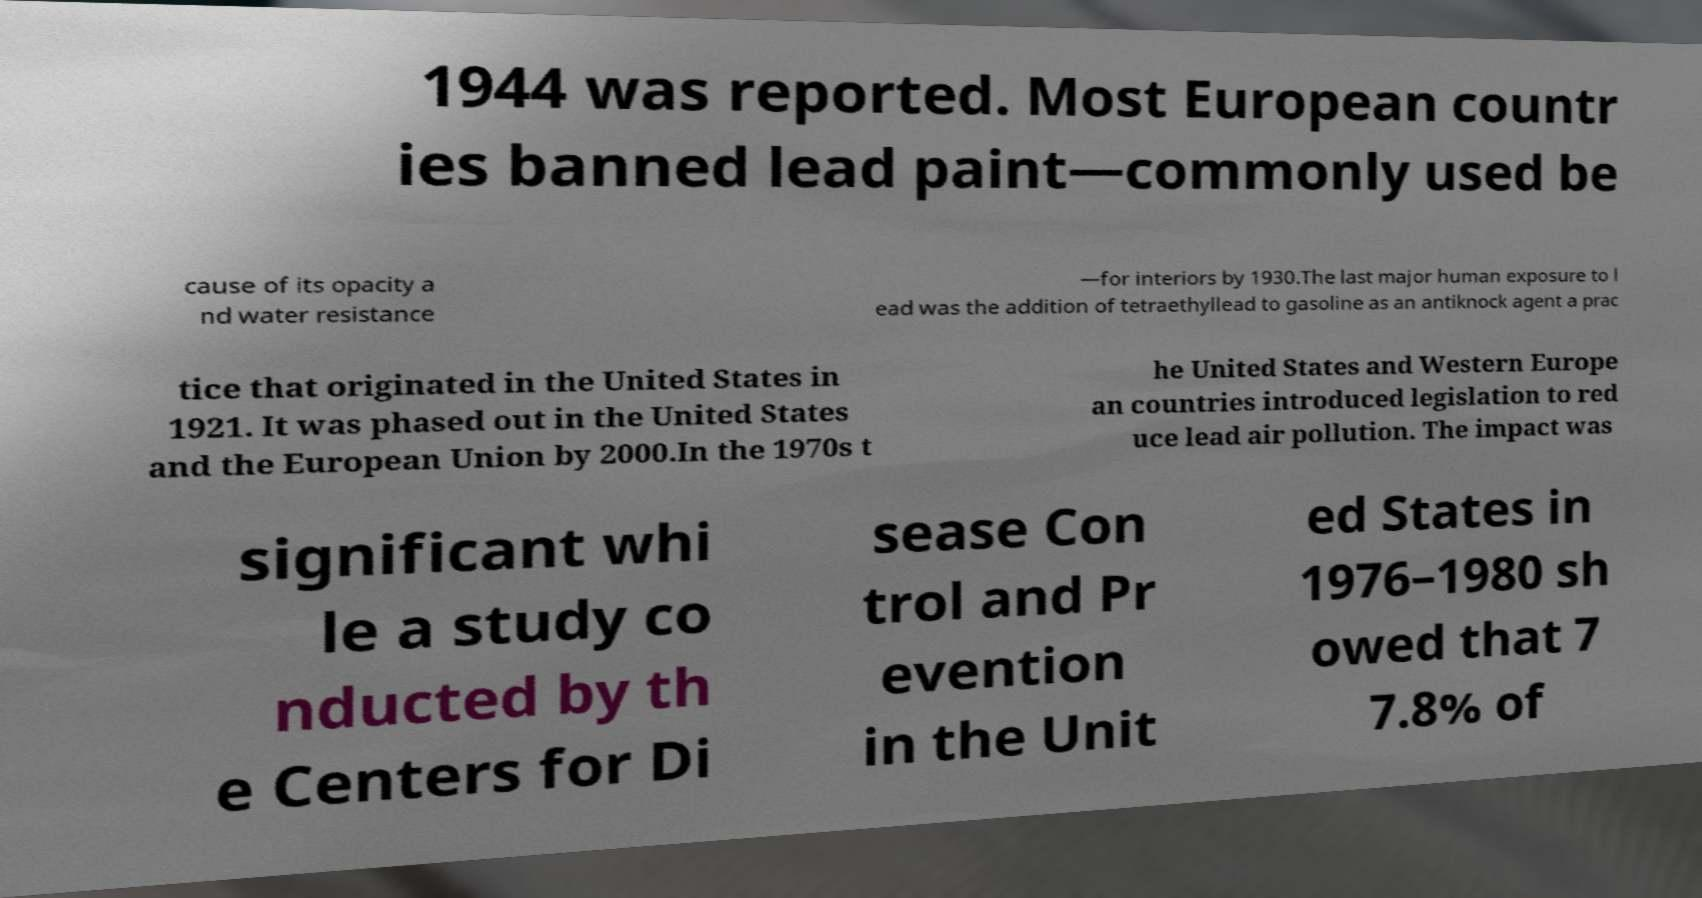Could you assist in decoding the text presented in this image and type it out clearly? 1944 was reported. Most European countr ies banned lead paint—commonly used be cause of its opacity a nd water resistance —for interiors by 1930.The last major human exposure to l ead was the addition of tetraethyllead to gasoline as an antiknock agent a prac tice that originated in the United States in 1921. It was phased out in the United States and the European Union by 2000.In the 1970s t he United States and Western Europe an countries introduced legislation to red uce lead air pollution. The impact was significant whi le a study co nducted by th e Centers for Di sease Con trol and Pr evention in the Unit ed States in 1976–1980 sh owed that 7 7.8% of 